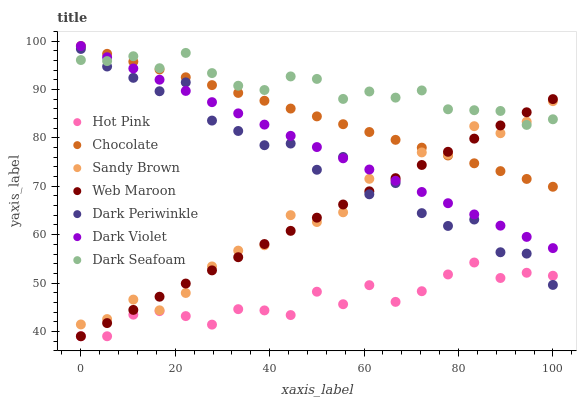Does Hot Pink have the minimum area under the curve?
Answer yes or no. Yes. Does Dark Seafoam have the maximum area under the curve?
Answer yes or no. Yes. Does Web Maroon have the minimum area under the curve?
Answer yes or no. No. Does Web Maroon have the maximum area under the curve?
Answer yes or no. No. Is Web Maroon the smoothest?
Answer yes or no. Yes. Is Dark Periwinkle the roughest?
Answer yes or no. Yes. Is Dark Violet the smoothest?
Answer yes or no. No. Is Dark Violet the roughest?
Answer yes or no. No. Does Hot Pink have the lowest value?
Answer yes or no. Yes. Does Dark Violet have the lowest value?
Answer yes or no. No. Does Chocolate have the highest value?
Answer yes or no. Yes. Does Web Maroon have the highest value?
Answer yes or no. No. Is Hot Pink less than Chocolate?
Answer yes or no. Yes. Is Sandy Brown greater than Hot Pink?
Answer yes or no. Yes. Does Dark Periwinkle intersect Sandy Brown?
Answer yes or no. Yes. Is Dark Periwinkle less than Sandy Brown?
Answer yes or no. No. Is Dark Periwinkle greater than Sandy Brown?
Answer yes or no. No. Does Hot Pink intersect Chocolate?
Answer yes or no. No. 